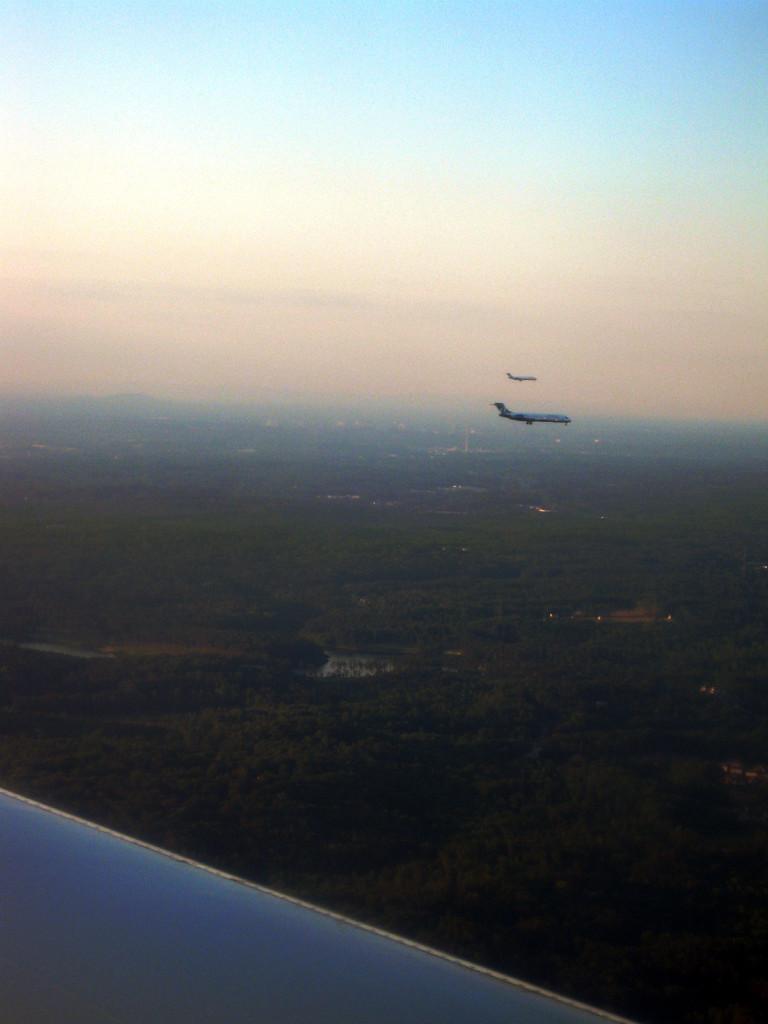Could you give a brief overview of what you see in this image? In this image, we can see aeroplanes in the sky and at the bottom, there are buildings and we can see trees and there is ground. 